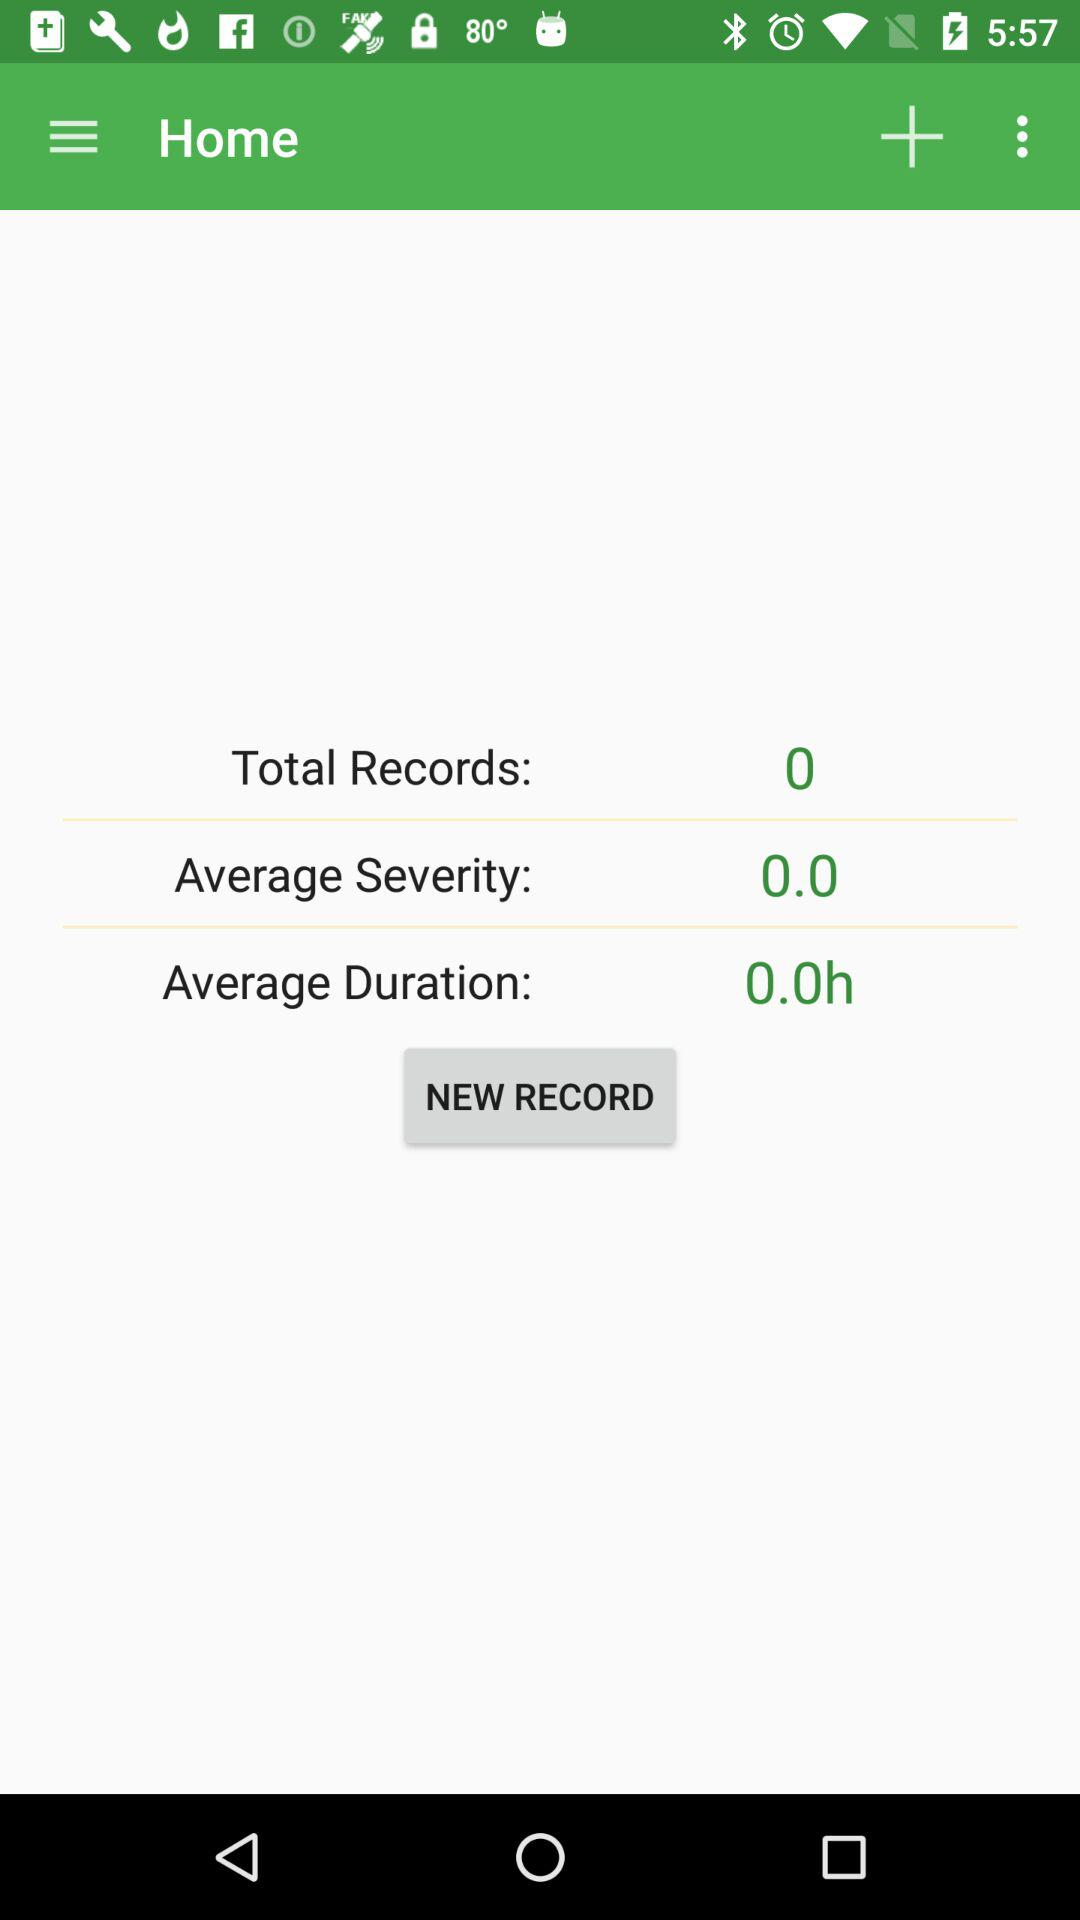What's the average duration? The average duration is 0 hours. 